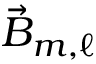<formula> <loc_0><loc_0><loc_500><loc_500>\vec { B } _ { m , \ell }</formula> 